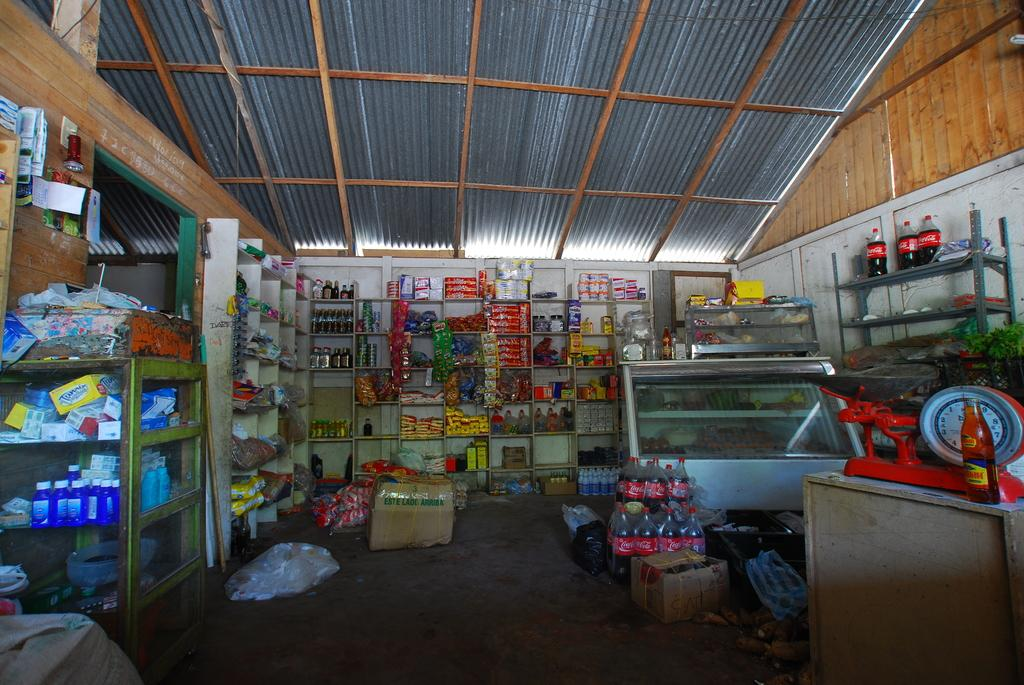<image>
Write a terse but informative summary of the picture. A storage room with many shelves are holding bottles of Coca Cola among other things. 